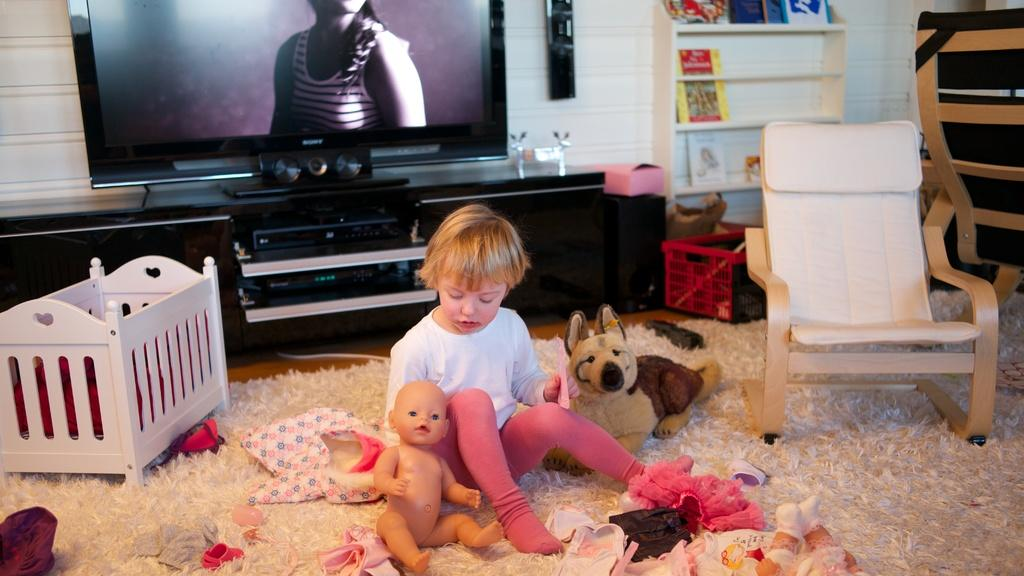What is the main subject in the middle of the image? There is a boy in the middle of the image. What is the boy sitting on? The boy is sitting on a mat. What other objects can be seen in the image? There are toys, a chair, and a box in the image. What can be seen in the background of the image? There is a television, a table, a wall, racks, and a speaker in the background. What color is the eye of the scarecrow in the image? There is no scarecrow present in the image, so there is no eye to describe. 